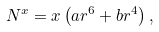<formula> <loc_0><loc_0><loc_500><loc_500>N ^ { x } = x \left ( a r ^ { 6 } + b r ^ { 4 } \right ) ,</formula> 